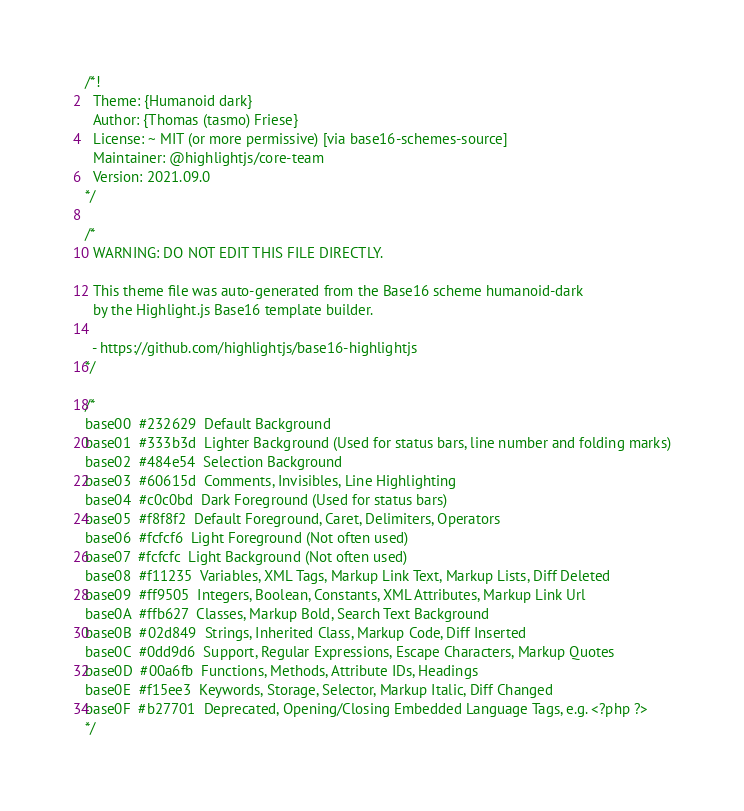Convert code to text. <code><loc_0><loc_0><loc_500><loc_500><_CSS_>/*!
  Theme: {Humanoid dark}
  Author: {Thomas (tasmo) Friese}
  License: ~ MIT (or more permissive) [via base16-schemes-source]
  Maintainer: @highlightjs/core-team
  Version: 2021.09.0
*/

/*
  WARNING: DO NOT EDIT THIS FILE DIRECTLY.

  This theme file was auto-generated from the Base16 scheme humanoid-dark
  by the Highlight.js Base16 template builder.

  - https://github.com/highlightjs/base16-highlightjs
*/

/*
base00  #232629  Default Background
base01  #333b3d  Lighter Background (Used for status bars, line number and folding marks)
base02  #484e54  Selection Background
base03  #60615d  Comments, Invisibles, Line Highlighting
base04  #c0c0bd  Dark Foreground (Used for status bars)
base05  #f8f8f2  Default Foreground, Caret, Delimiters, Operators
base06  #fcfcf6  Light Foreground (Not often used)
base07  #fcfcfc  Light Background (Not often used)
base08  #f11235  Variables, XML Tags, Markup Link Text, Markup Lists, Diff Deleted
base09  #ff9505  Integers, Boolean, Constants, XML Attributes, Markup Link Url
base0A  #ffb627  Classes, Markup Bold, Search Text Background
base0B  #02d849  Strings, Inherited Class, Markup Code, Diff Inserted
base0C  #0dd9d6  Support, Regular Expressions, Escape Characters, Markup Quotes
base0D  #00a6fb  Functions, Methods, Attribute IDs, Headings
base0E  #f15ee3  Keywords, Storage, Selector, Markup Italic, Diff Changed
base0F  #b27701  Deprecated, Opening/Closing Embedded Language Tags, e.g. <?php ?>
*/
</code> 